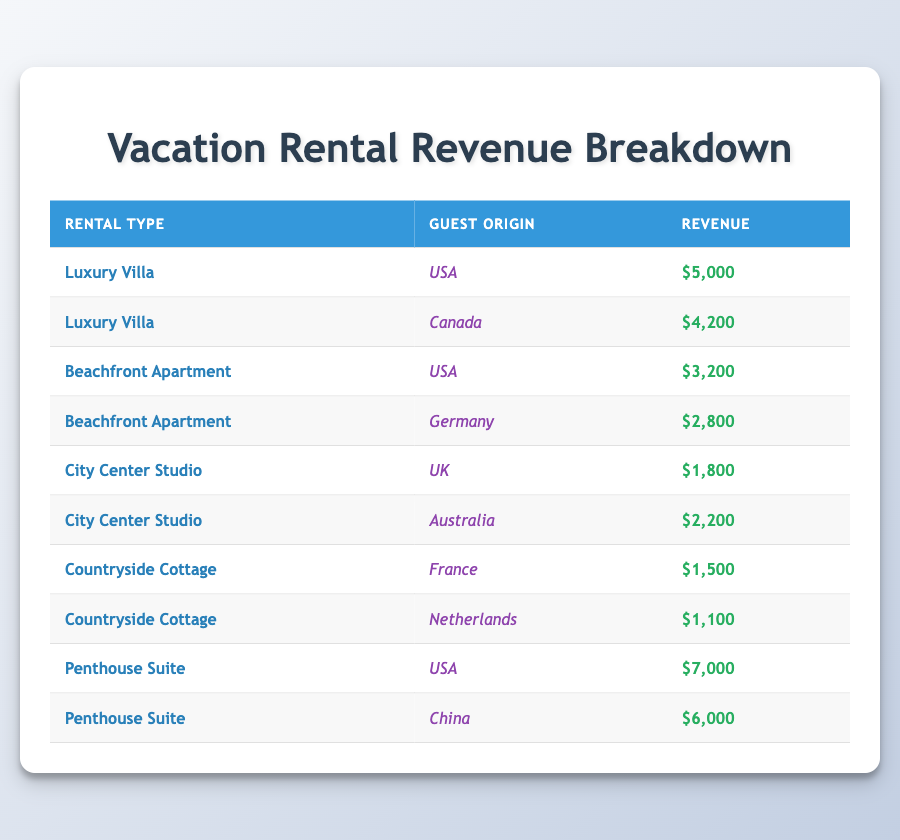What is the total revenue generated from the Luxury Villa rentals? The Luxury Villa rentals are from two origins: USA ($5,000) and Canada ($4,200). To find the total revenue, we sum these two amounts: $5,000 + $4,200 = $9,200.
Answer: $9,200 Which guest origin contributed the highest revenue for the Penthouse Suite? There are two entries for the Penthouse Suite: USA with $7,000 and China with $6,000. The higher amount is from the USA at $7,000.
Answer: USA Is the total revenue from Beachfront Apartments greater than the revenue from City Center Studios? The total revenue from Beachfront Apartments is $3,200 (USA) + $2,800 (Germany) = $6,000. The total revenue from City Center Studios is $1,800 (UK) + $2,200 (Australia) = $4,000. Since $6,000 > $4,000, the statement is true.
Answer: Yes What is the average revenue per rental type? We have four rental types: Luxury Villa, Beachfront Apartment, City Center Studio, and Countryside Cottage. Calculate total revenue for each: Luxury Villa = $9,200, Beachfront Apartment = $6,000, City Center Studio = $4,000, Countryside Cottage = $2,600. The total revenue is $9,200 + $6,000 + $4,000 + $2,600 = $21,800. There are four rental types, so average revenue is $21,800 / 4 = $5,450.
Answer: $5,450 Which guest origin represents the least revenue for the Countryside Cottage? The two entries for Countryside Cottage are from France with $1,500 and Netherlands with $1,100. The lower revenue is from the Netherlands at $1,100.
Answer: Netherlands 